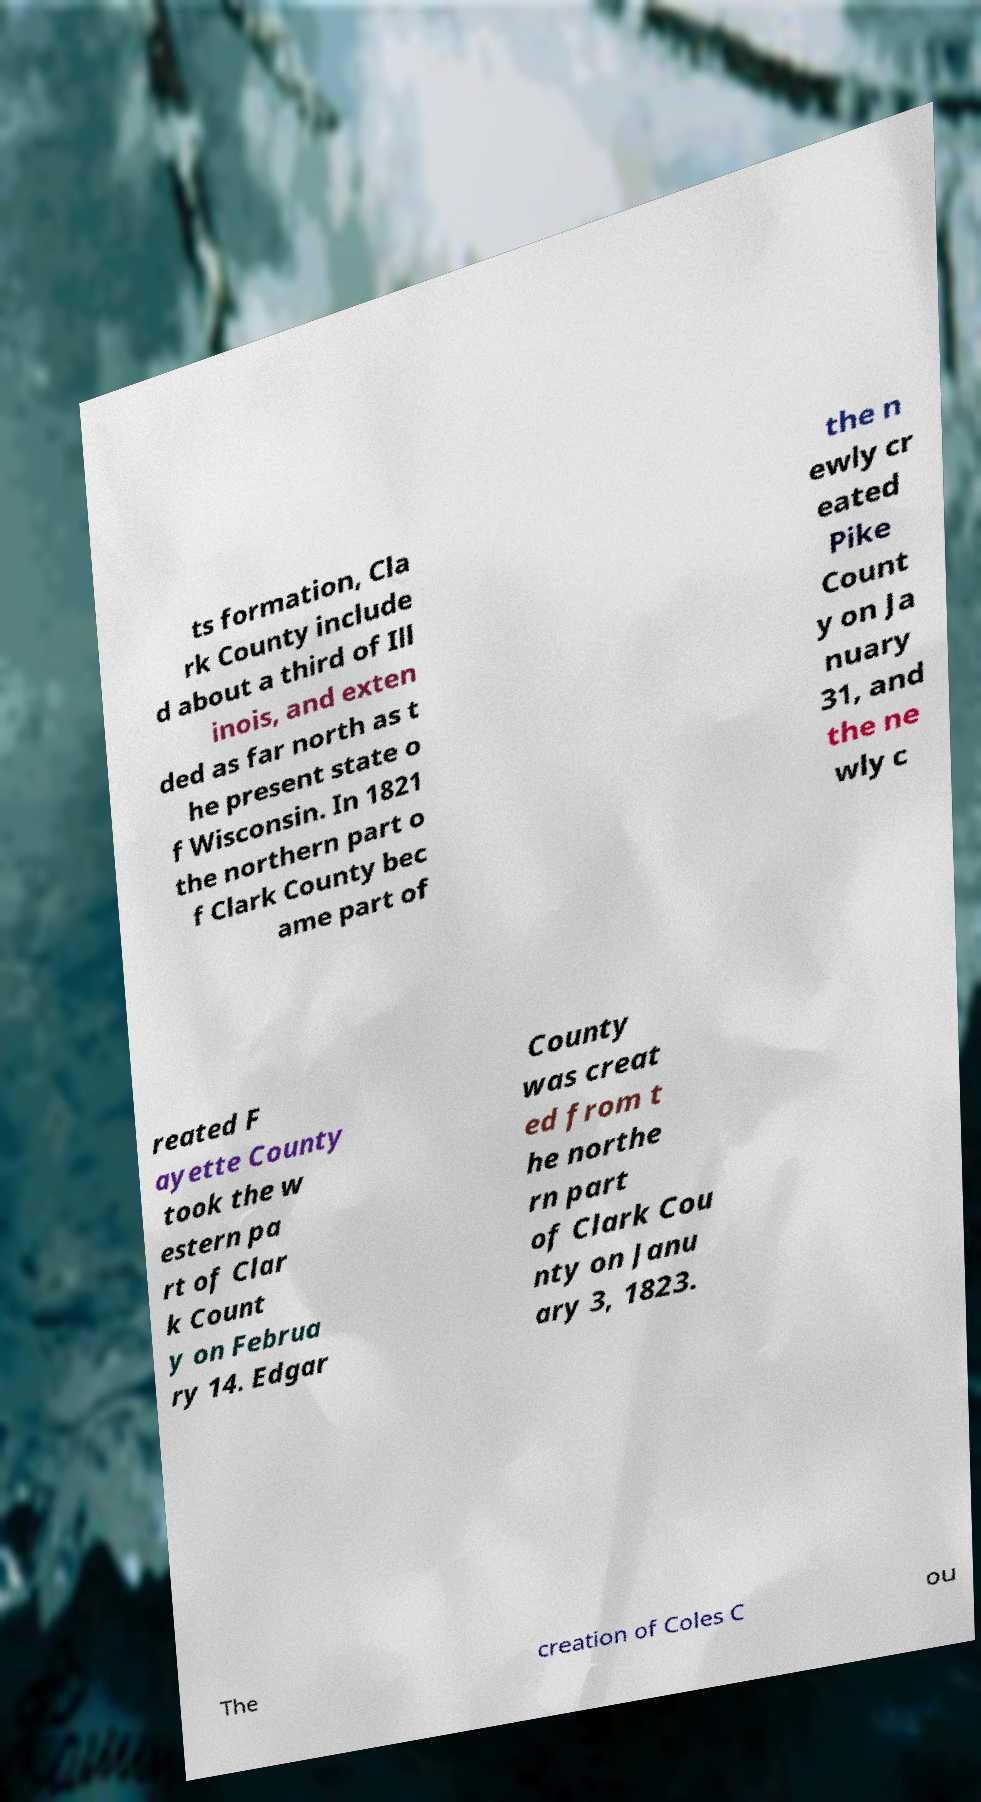I need the written content from this picture converted into text. Can you do that? ts formation, Cla rk County include d about a third of Ill inois, and exten ded as far north as t he present state o f Wisconsin. In 1821 the northern part o f Clark County bec ame part of the n ewly cr eated Pike Count y on Ja nuary 31, and the ne wly c reated F ayette County took the w estern pa rt of Clar k Count y on Februa ry 14. Edgar County was creat ed from t he northe rn part of Clark Cou nty on Janu ary 3, 1823. The creation of Coles C ou 